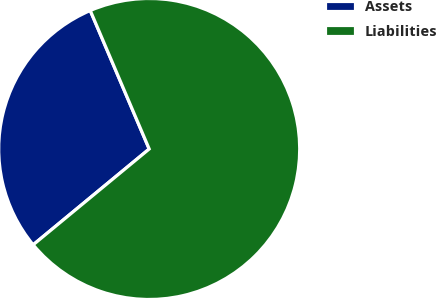Convert chart. <chart><loc_0><loc_0><loc_500><loc_500><pie_chart><fcel>Assets<fcel>Liabilities<nl><fcel>29.58%<fcel>70.42%<nl></chart> 